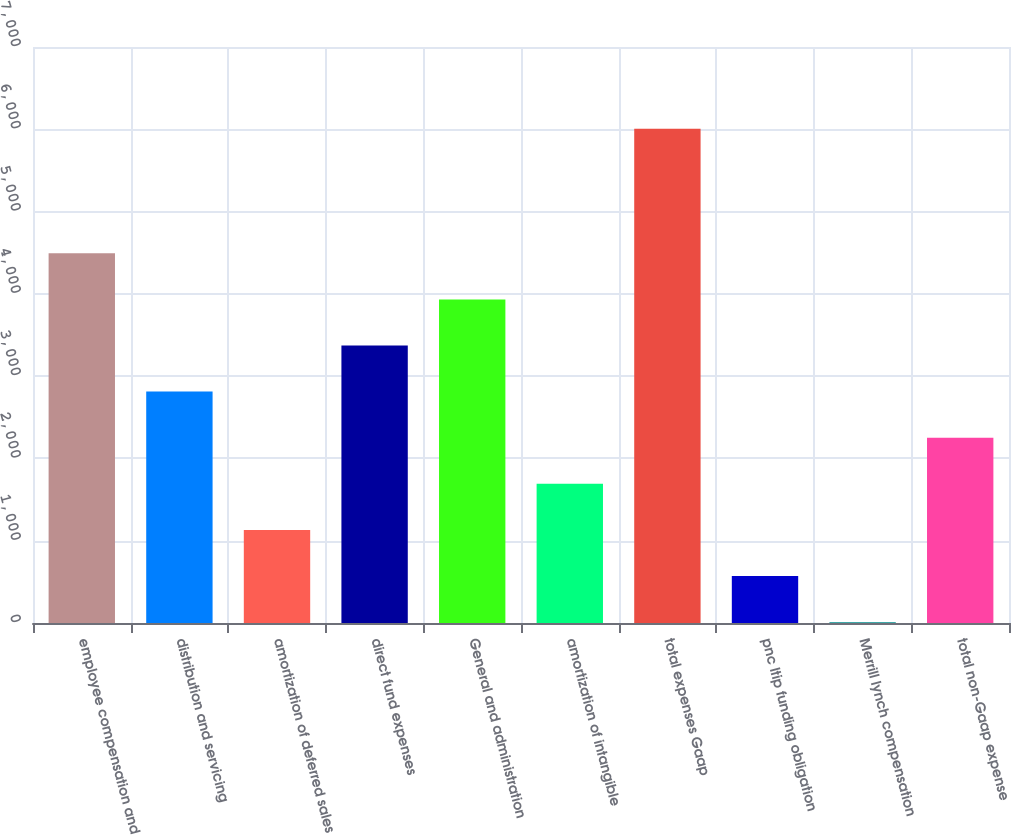Convert chart to OTSL. <chart><loc_0><loc_0><loc_500><loc_500><bar_chart><fcel>employee compensation and<fcel>distribution and servicing<fcel>amortization of deferred sales<fcel>direct fund expenses<fcel>General and administration<fcel>amortization of intangible<fcel>total expenses Gaap<fcel>pnc ltip funding obligation<fcel>Merrill lynch compensation<fcel>total non-Gaap expense<nl><fcel>4493.2<fcel>2812<fcel>1130.8<fcel>3372.4<fcel>3932.8<fcel>1691.2<fcel>6005.4<fcel>570.4<fcel>10<fcel>2251.6<nl></chart> 